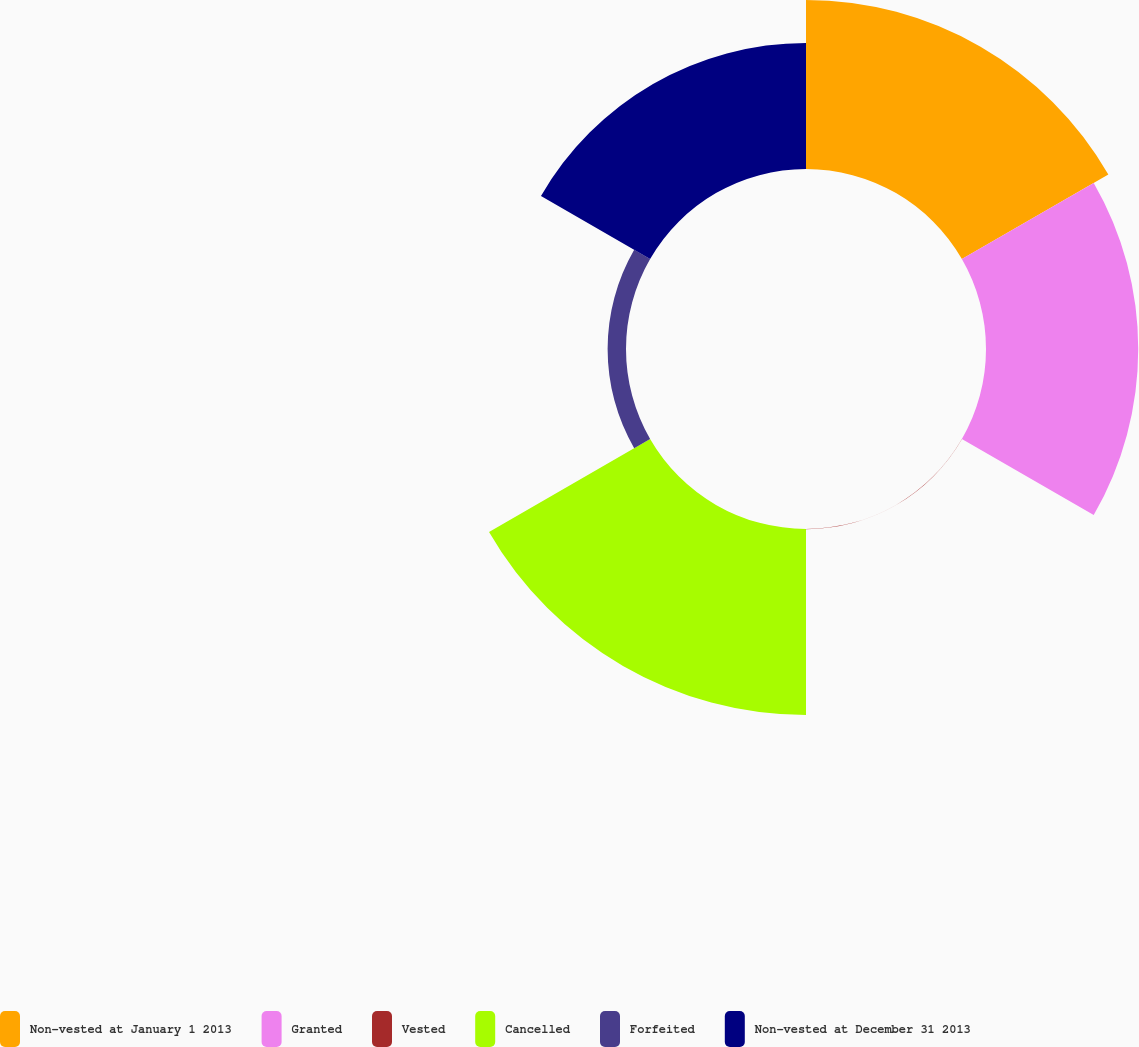<chart> <loc_0><loc_0><loc_500><loc_500><pie_chart><fcel>Non-vested at January 1 2013<fcel>Granted<fcel>Vested<fcel>Cancelled<fcel>Forfeited<fcel>Non-vested at December 31 2013<nl><fcel>25.94%<fcel>23.35%<fcel>0.03%<fcel>28.53%<fcel>2.82%<fcel>19.33%<nl></chart> 